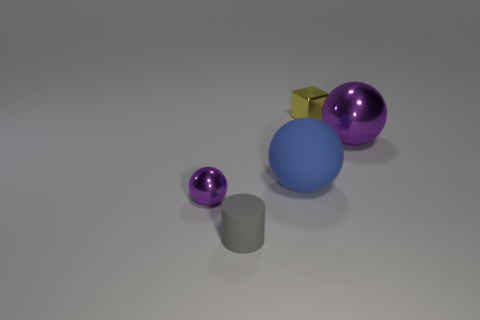Add 4 big purple metal spheres. How many objects exist? 9 Subtract all balls. How many objects are left? 2 Add 5 blue objects. How many blue objects are left? 6 Add 4 large cyan rubber things. How many large cyan rubber things exist? 4 Subtract 0 green cubes. How many objects are left? 5 Subtract all big cyan matte spheres. Subtract all tiny yellow blocks. How many objects are left? 4 